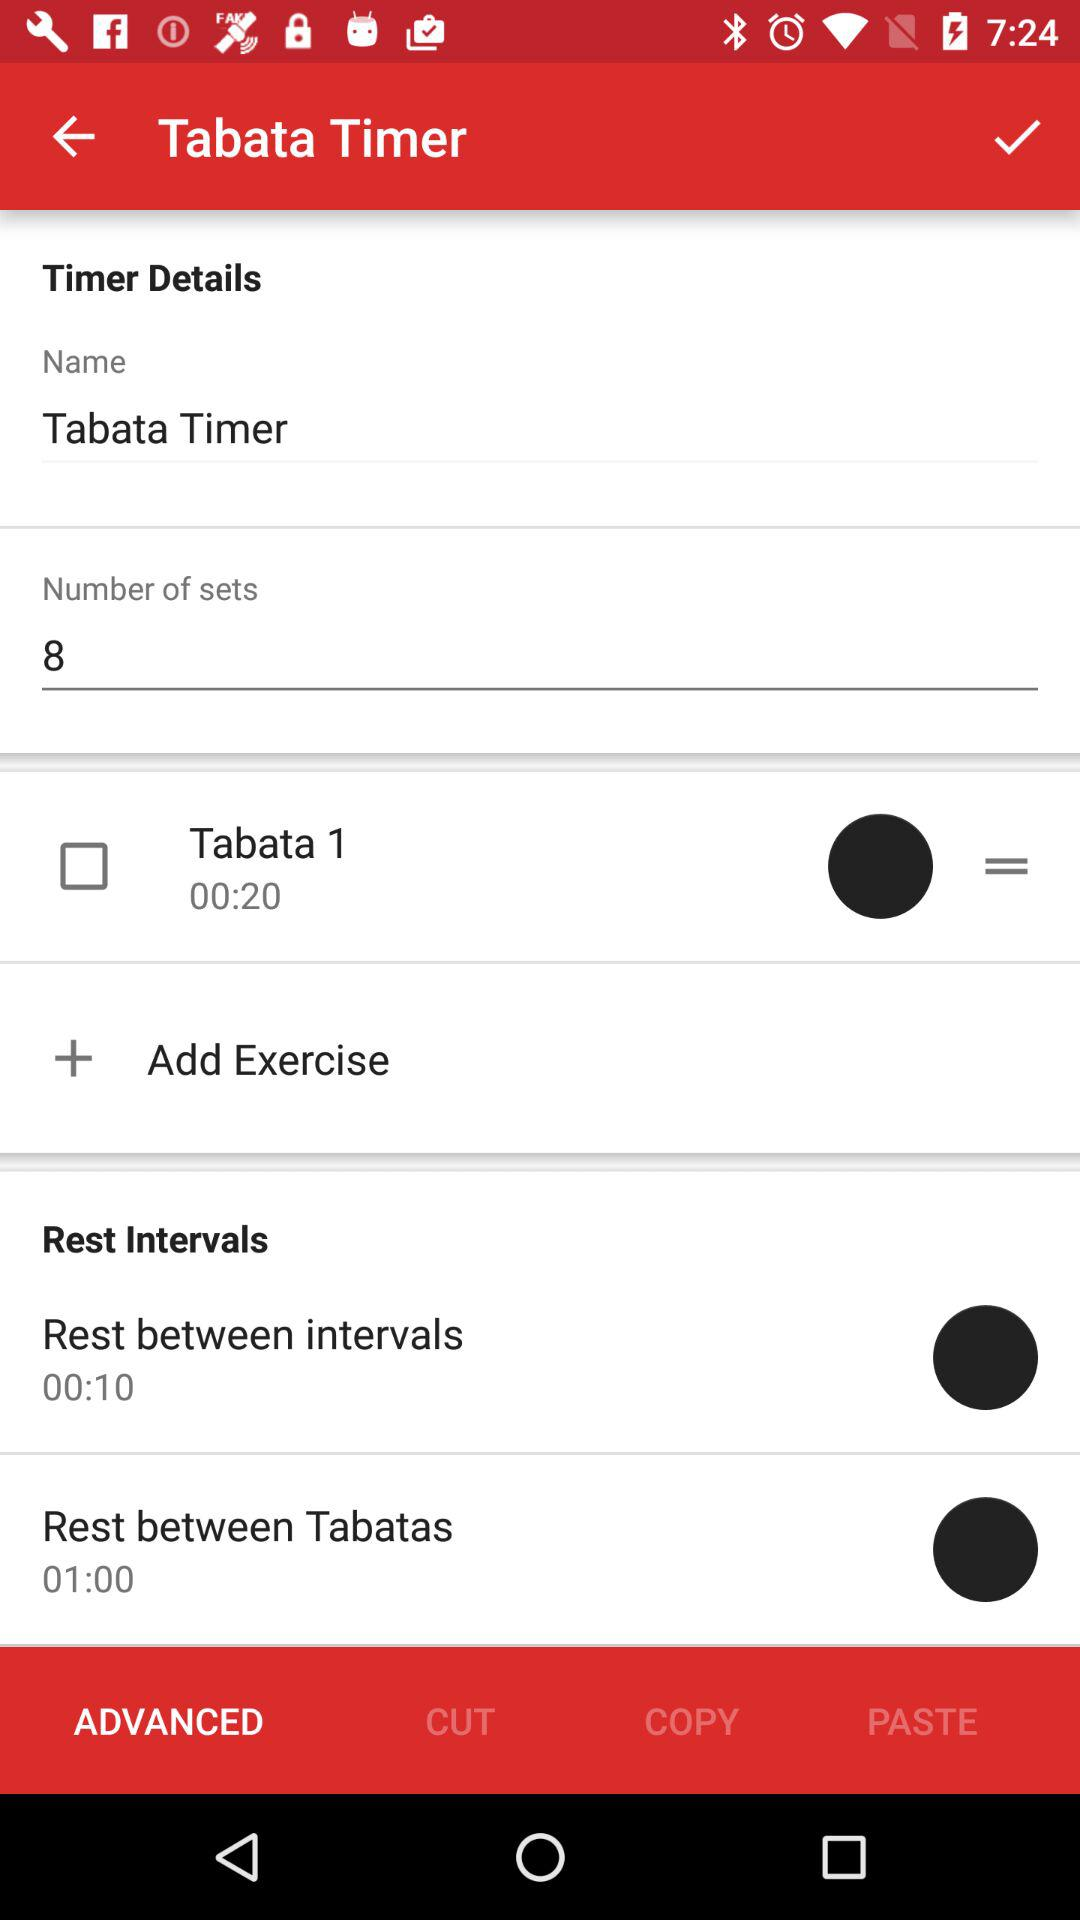Which "Rest Intervals" has a duration of 01:00? The "Rest between Tabatas" has a duration of 01:00. 